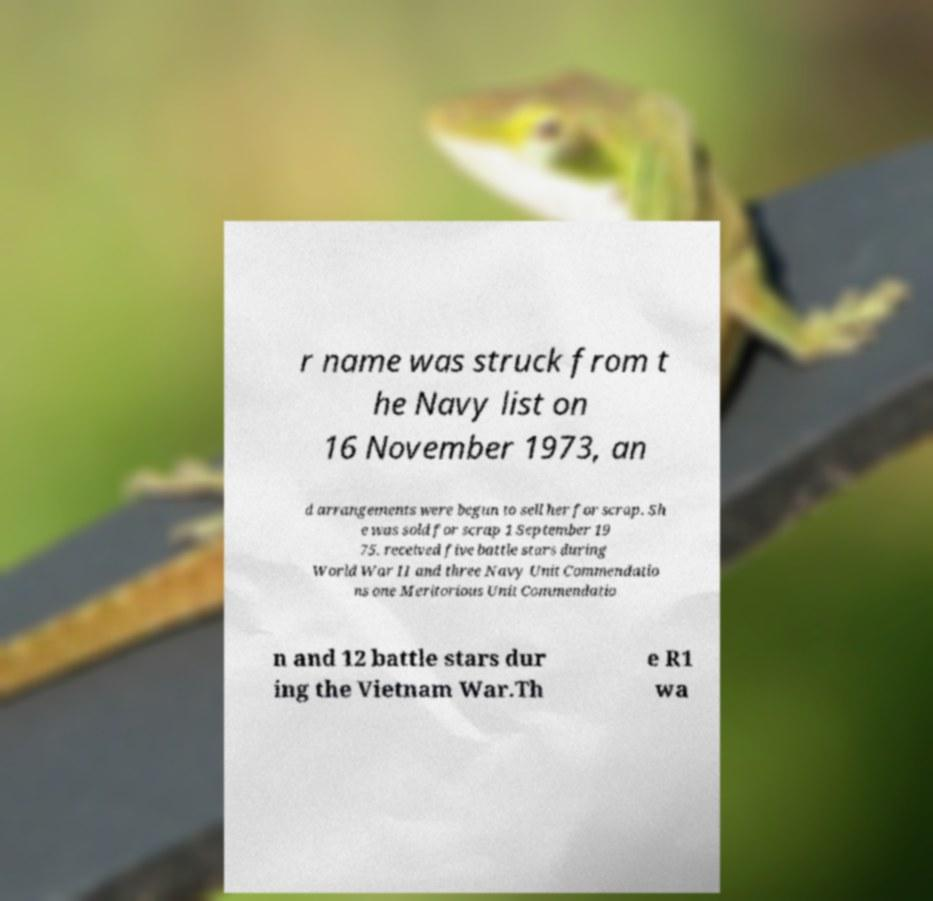There's text embedded in this image that I need extracted. Can you transcribe it verbatim? r name was struck from t he Navy list on 16 November 1973, an d arrangements were begun to sell her for scrap. Sh e was sold for scrap 1 September 19 75. received five battle stars during World War II and three Navy Unit Commendatio ns one Meritorious Unit Commendatio n and 12 battle stars dur ing the Vietnam War.Th e R1 wa 